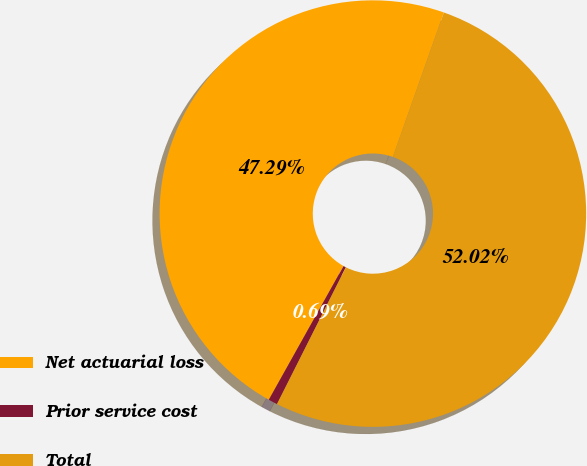<chart> <loc_0><loc_0><loc_500><loc_500><pie_chart><fcel>Net actuarial loss<fcel>Prior service cost<fcel>Total<nl><fcel>47.29%<fcel>0.69%<fcel>52.02%<nl></chart> 